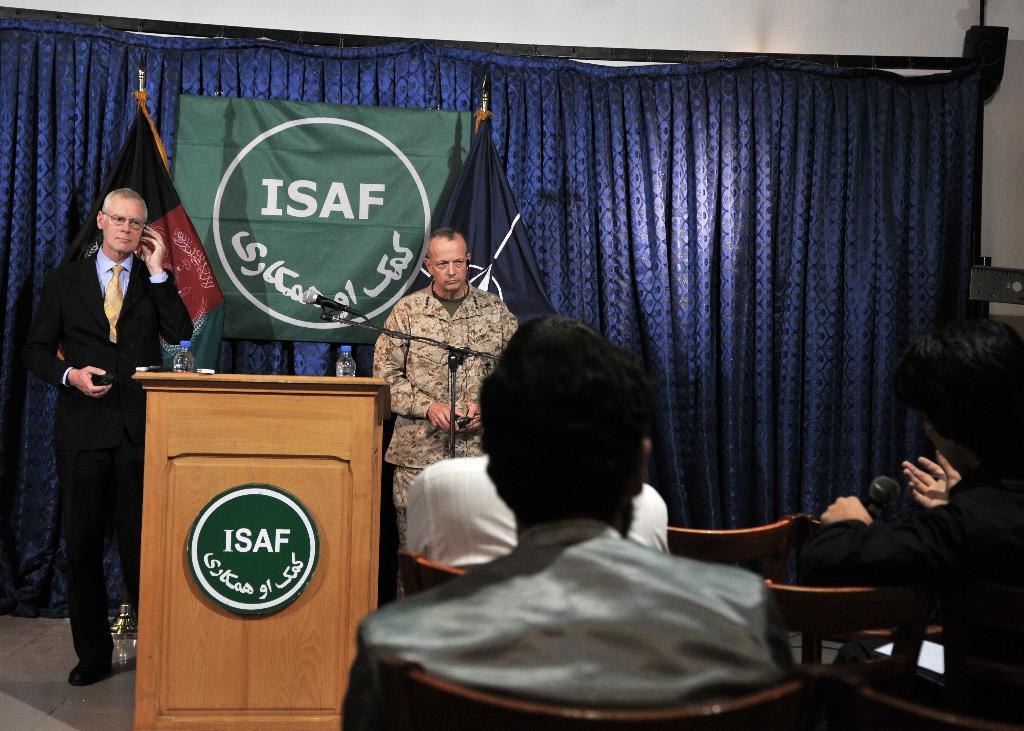<image>
Render a clear and concise summary of the photo. ISAF meeting with one man on cellphone and other man in uniform next to podium. 